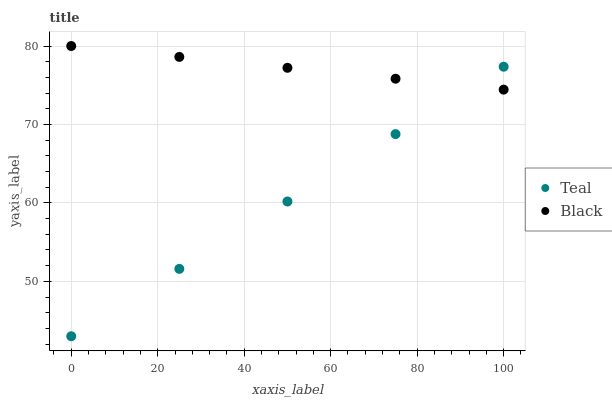Does Teal have the minimum area under the curve?
Answer yes or no. Yes. Does Black have the maximum area under the curve?
Answer yes or no. Yes. Does Teal have the maximum area under the curve?
Answer yes or no. No. Is Teal the smoothest?
Answer yes or no. Yes. Is Black the roughest?
Answer yes or no. Yes. Is Teal the roughest?
Answer yes or no. No. Does Teal have the lowest value?
Answer yes or no. Yes. Does Black have the highest value?
Answer yes or no. Yes. Does Teal have the highest value?
Answer yes or no. No. Does Teal intersect Black?
Answer yes or no. Yes. Is Teal less than Black?
Answer yes or no. No. Is Teal greater than Black?
Answer yes or no. No. 